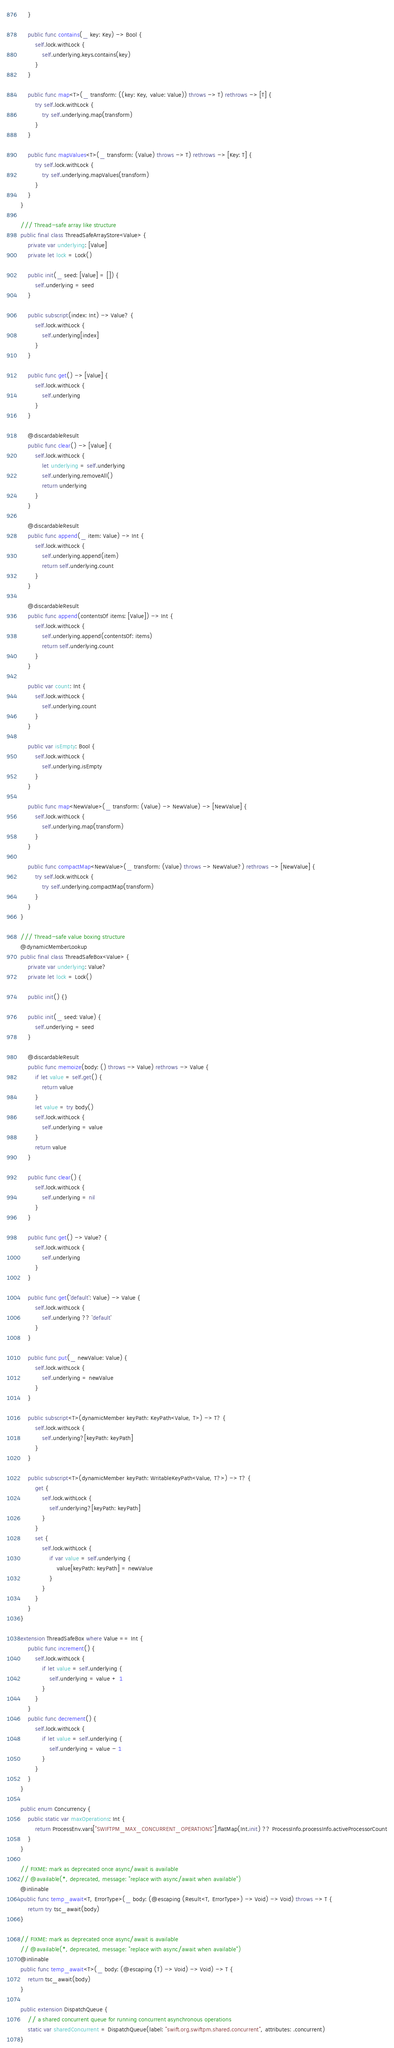<code> <loc_0><loc_0><loc_500><loc_500><_Swift_>    }

    public func contains(_ key: Key) -> Bool {
        self.lock.withLock {
            self.underlying.keys.contains(key)
        }
    }

    public func map<T>(_ transform: ((key: Key, value: Value)) throws -> T) rethrows -> [T] {
        try self.lock.withLock {
            try self.underlying.map(transform)
        }
    }

    public func mapValues<T>(_ transform: (Value) throws -> T) rethrows -> [Key: T] {
        try self.lock.withLock {
            try self.underlying.mapValues(transform)
        }
    }
}

/// Thread-safe array like structure
public final class ThreadSafeArrayStore<Value> {
    private var underlying: [Value]
    private let lock = Lock()

    public init(_ seed: [Value] = []) {
        self.underlying = seed
    }

    public subscript(index: Int) -> Value? {
        self.lock.withLock {
            self.underlying[index]
        }
    }

    public func get() -> [Value] {
        self.lock.withLock {
            self.underlying
        }
    }

    @discardableResult
    public func clear() -> [Value] {
        self.lock.withLock {
            let underlying = self.underlying
            self.underlying.removeAll()
            return underlying
        }
    }

    @discardableResult
    public func append(_ item: Value) -> Int {
        self.lock.withLock {
            self.underlying.append(item)
            return self.underlying.count
        }
    }

    @discardableResult
    public func append(contentsOf items: [Value]) -> Int {
        self.lock.withLock {
            self.underlying.append(contentsOf: items)
            return self.underlying.count
        }
    }

    public var count: Int {
        self.lock.withLock {
            self.underlying.count
        }
    }

    public var isEmpty: Bool {
        self.lock.withLock {
            self.underlying.isEmpty
        }
    }

    public func map<NewValue>(_ transform: (Value) -> NewValue) -> [NewValue] {
        self.lock.withLock {
            self.underlying.map(transform)
        }
    }

    public func compactMap<NewValue>(_ transform: (Value) throws -> NewValue?) rethrows -> [NewValue] {
        try self.lock.withLock {
            try self.underlying.compactMap(transform)
        }
    }
}

/// Thread-safe value boxing structure
@dynamicMemberLookup
public final class ThreadSafeBox<Value> {
    private var underlying: Value?
    private let lock = Lock()

    public init() {}

    public init(_ seed: Value) {
        self.underlying = seed
    }

    @discardableResult
    public func memoize(body: () throws -> Value) rethrows -> Value {
        if let value = self.get() {
            return value
        }
        let value = try body()
        self.lock.withLock {
            self.underlying = value
        }
        return value
    }

    public func clear() {
        self.lock.withLock {
            self.underlying = nil
        }
    }

    public func get() -> Value? {
        self.lock.withLock {
            self.underlying
        }
    }

    public func get(`default`: Value) -> Value {
        self.lock.withLock {
            self.underlying ?? `default`
        }
    }

    public func put(_ newValue: Value) {
        self.lock.withLock {
            self.underlying = newValue
        }
    }

    public subscript<T>(dynamicMember keyPath: KeyPath<Value, T>) -> T? {
        self.lock.withLock {
            self.underlying?[keyPath: keyPath]
        }
    }

    public subscript<T>(dynamicMember keyPath: WritableKeyPath<Value, T?>) -> T? {
        get {
            self.lock.withLock {
                self.underlying?[keyPath: keyPath]
            }
        }
        set {
            self.lock.withLock {
                if var value = self.underlying {
                    value[keyPath: keyPath] = newValue
                }
            }
        }
    }
}

extension ThreadSafeBox where Value == Int {
    public func increment() {
        self.lock.withLock {
            if let value = self.underlying {
                self.underlying = value + 1
            }
        }
    }
    public func decrement() {
        self.lock.withLock {
            if let value = self.underlying {
                self.underlying = value - 1
            }
        }
    }
}

public enum Concurrency {
    public static var maxOperations: Int {
        return ProcessEnv.vars["SWIFTPM_MAX_CONCURRENT_OPERATIONS"].flatMap(Int.init) ?? ProcessInfo.processInfo.activeProcessorCount
    }
}

// FIXME: mark as deprecated once async/await is available
// @available(*, deprecated, message: "replace with async/await when available")
@inlinable
public func temp_await<T, ErrorType>(_ body: (@escaping (Result<T, ErrorType>) -> Void) -> Void) throws -> T {
    return try tsc_await(body)
}

// FIXME: mark as deprecated once async/await is available
// @available(*, deprecated, message: "replace with async/await when available")
@inlinable
public func temp_await<T>(_ body: (@escaping (T) -> Void) -> Void) -> T {
    return tsc_await(body)
}

public extension DispatchQueue {
    // a shared concurrent queue for running concurrent asynchronous operations
    static var sharedConcurrent = DispatchQueue(label: "swift.org.swiftpm.shared.concurrent", attributes: .concurrent)
}
</code> 